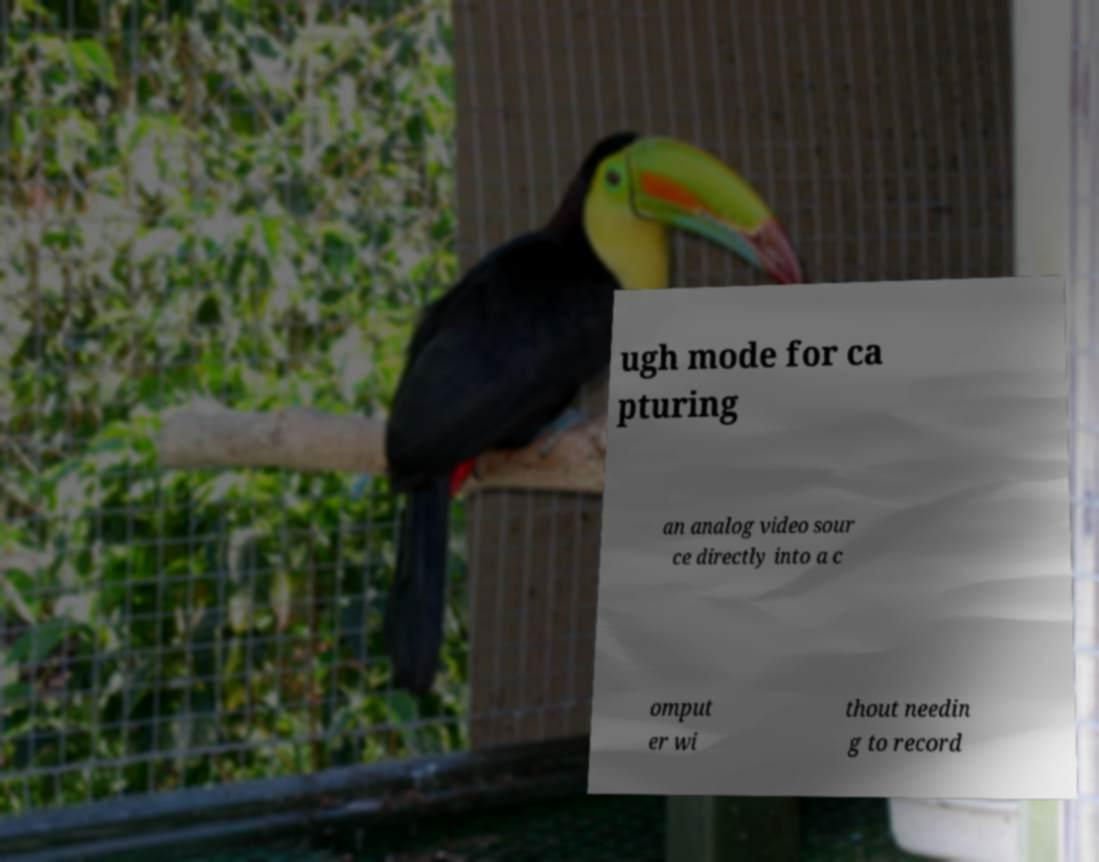Can you accurately transcribe the text from the provided image for me? ugh mode for ca pturing an analog video sour ce directly into a c omput er wi thout needin g to record 